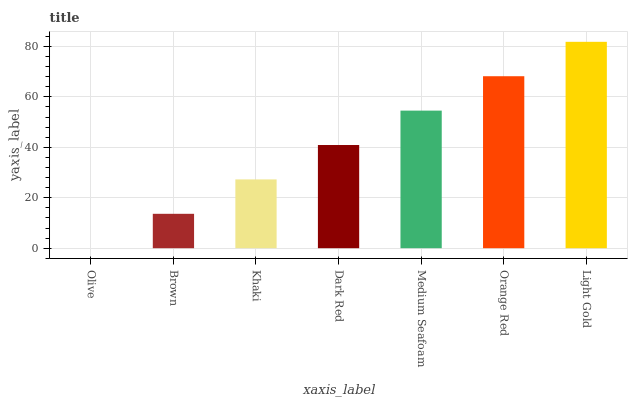Is Olive the minimum?
Answer yes or no. Yes. Is Light Gold the maximum?
Answer yes or no. Yes. Is Brown the minimum?
Answer yes or no. No. Is Brown the maximum?
Answer yes or no. No. Is Brown greater than Olive?
Answer yes or no. Yes. Is Olive less than Brown?
Answer yes or no. Yes. Is Olive greater than Brown?
Answer yes or no. No. Is Brown less than Olive?
Answer yes or no. No. Is Dark Red the high median?
Answer yes or no. Yes. Is Dark Red the low median?
Answer yes or no. Yes. Is Orange Red the high median?
Answer yes or no. No. Is Light Gold the low median?
Answer yes or no. No. 